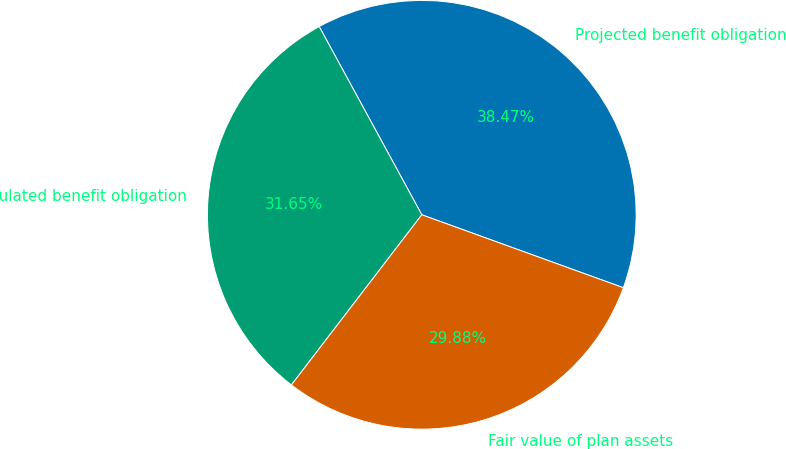<chart> <loc_0><loc_0><loc_500><loc_500><pie_chart><fcel>Projected benefit obligation<fcel>Accumulated benefit obligation<fcel>Fair value of plan assets<nl><fcel>38.47%<fcel>31.65%<fcel>29.88%<nl></chart> 